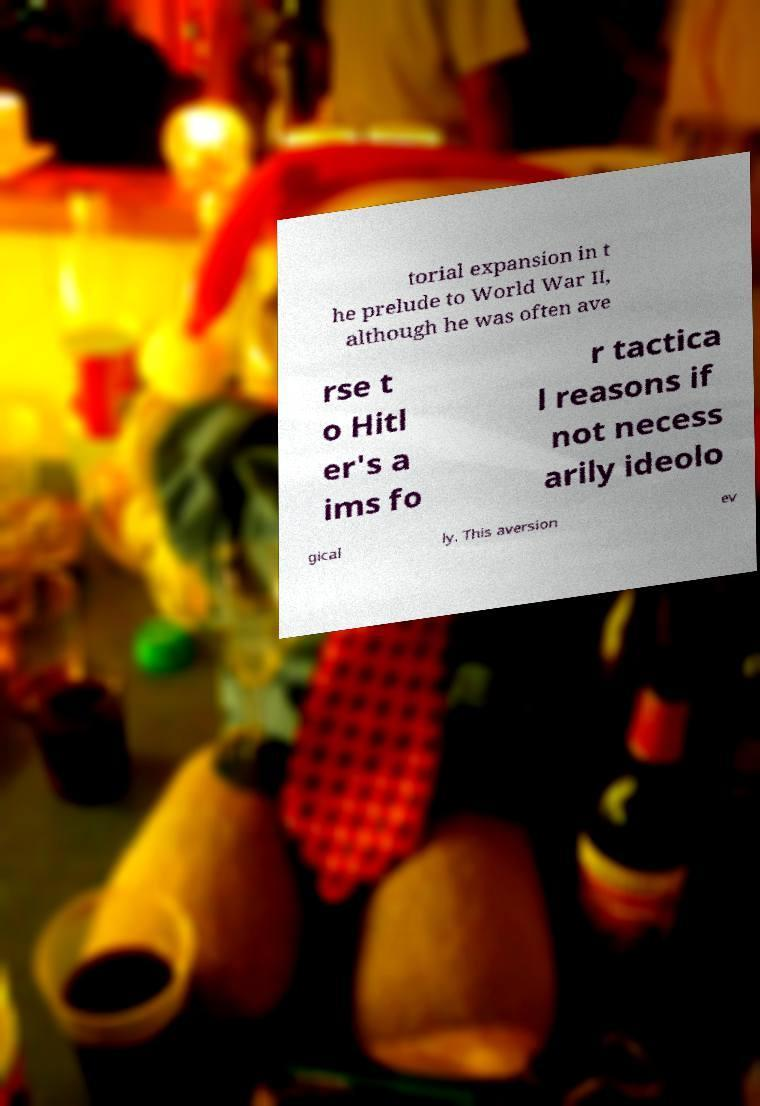Please read and relay the text visible in this image. What does it say? torial expansion in t he prelude to World War II, although he was often ave rse t o Hitl er's a ims fo r tactica l reasons if not necess arily ideolo gical ly. This aversion ev 